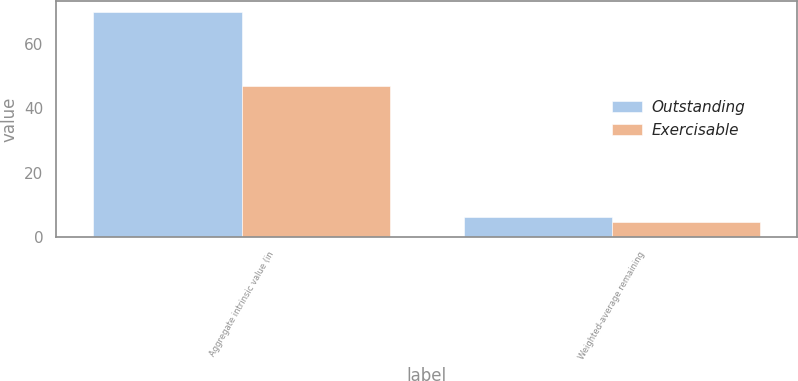Convert chart. <chart><loc_0><loc_0><loc_500><loc_500><stacked_bar_chart><ecel><fcel>Aggregate intrinsic value (in<fcel>Weighted-average remaining<nl><fcel>Outstanding<fcel>70<fcel>6.1<nl><fcel>Exercisable<fcel>47<fcel>4.7<nl></chart> 